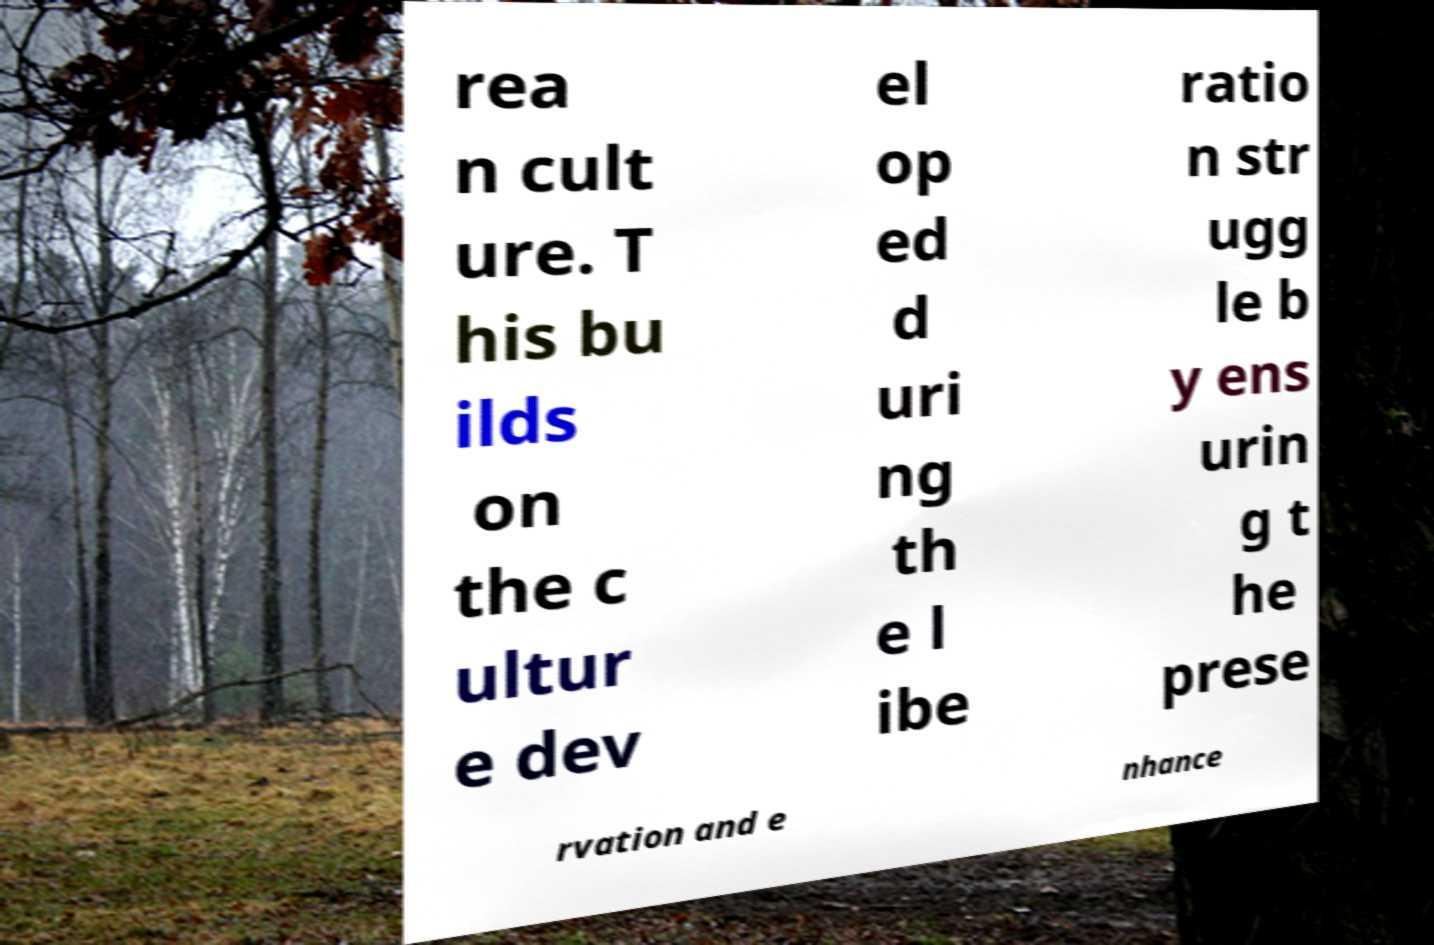Could you extract and type out the text from this image? rea n cult ure. T his bu ilds on the c ultur e dev el op ed d uri ng th e l ibe ratio n str ugg le b y ens urin g t he prese rvation and e nhance 